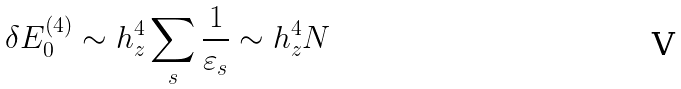Convert formula to latex. <formula><loc_0><loc_0><loc_500><loc_500>\delta E _ { 0 } ^ { ( 4 ) } \sim h _ { z } ^ { 4 } \sum _ { s } \frac { 1 } { \varepsilon _ { s } } \sim h _ { z } ^ { 4 } N</formula> 